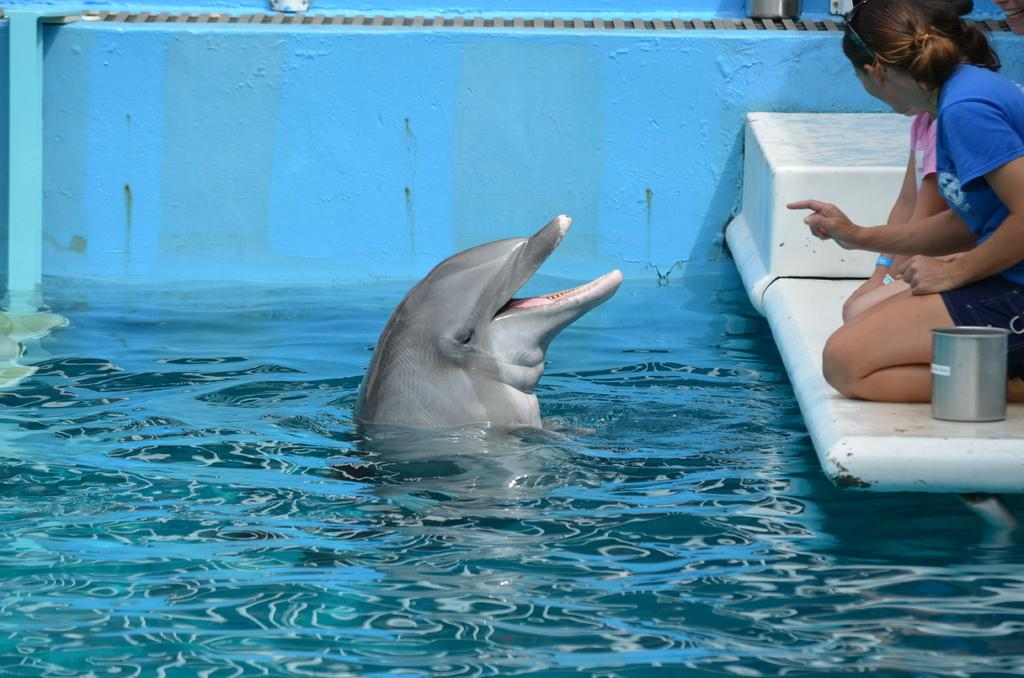Who or what can be seen in the image? There are people and a dolphin in the image. What is the environment like in the image? There is water visible in the image. What is the color of the wall in the image? There is a blue color wall in the image. What is present at the top side of the image? There are objects present in the top side of the image. How many sacks can be seen in the image? There are no sacks present in the image. Can you tell me if the dolphin is jumping in the image? The image does not show the dolphin jumping; it is in the water with the people. 